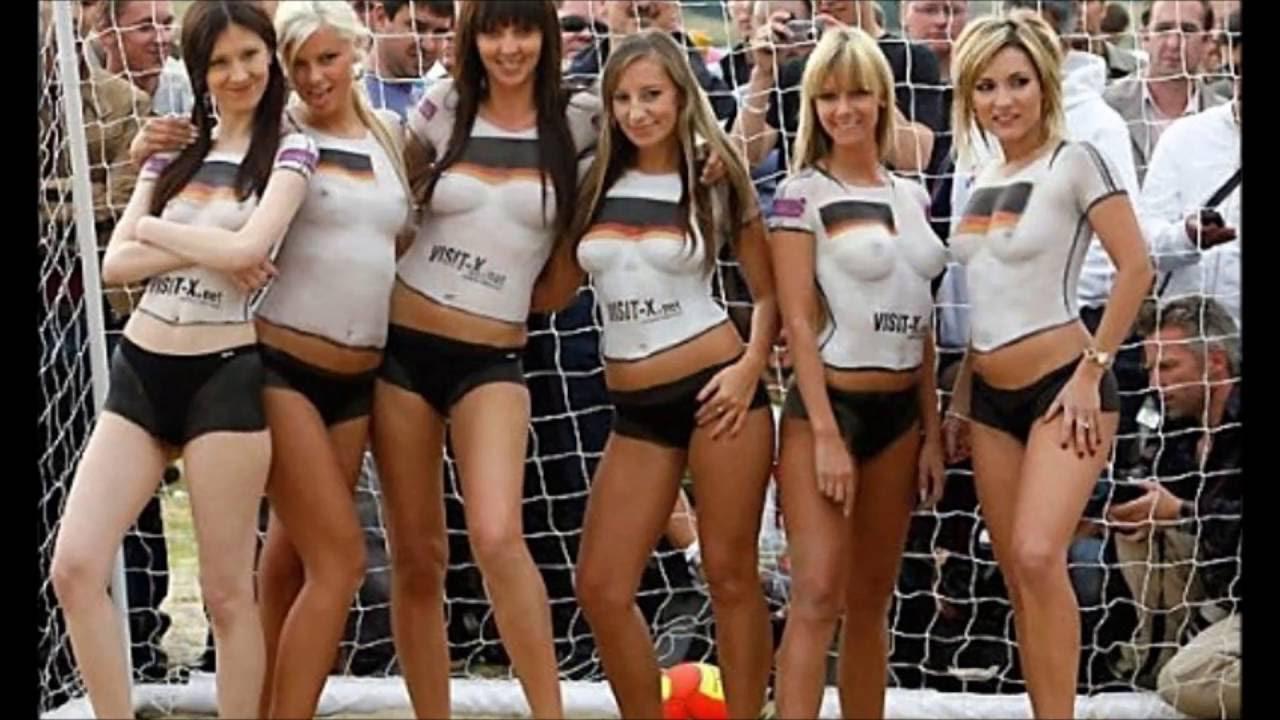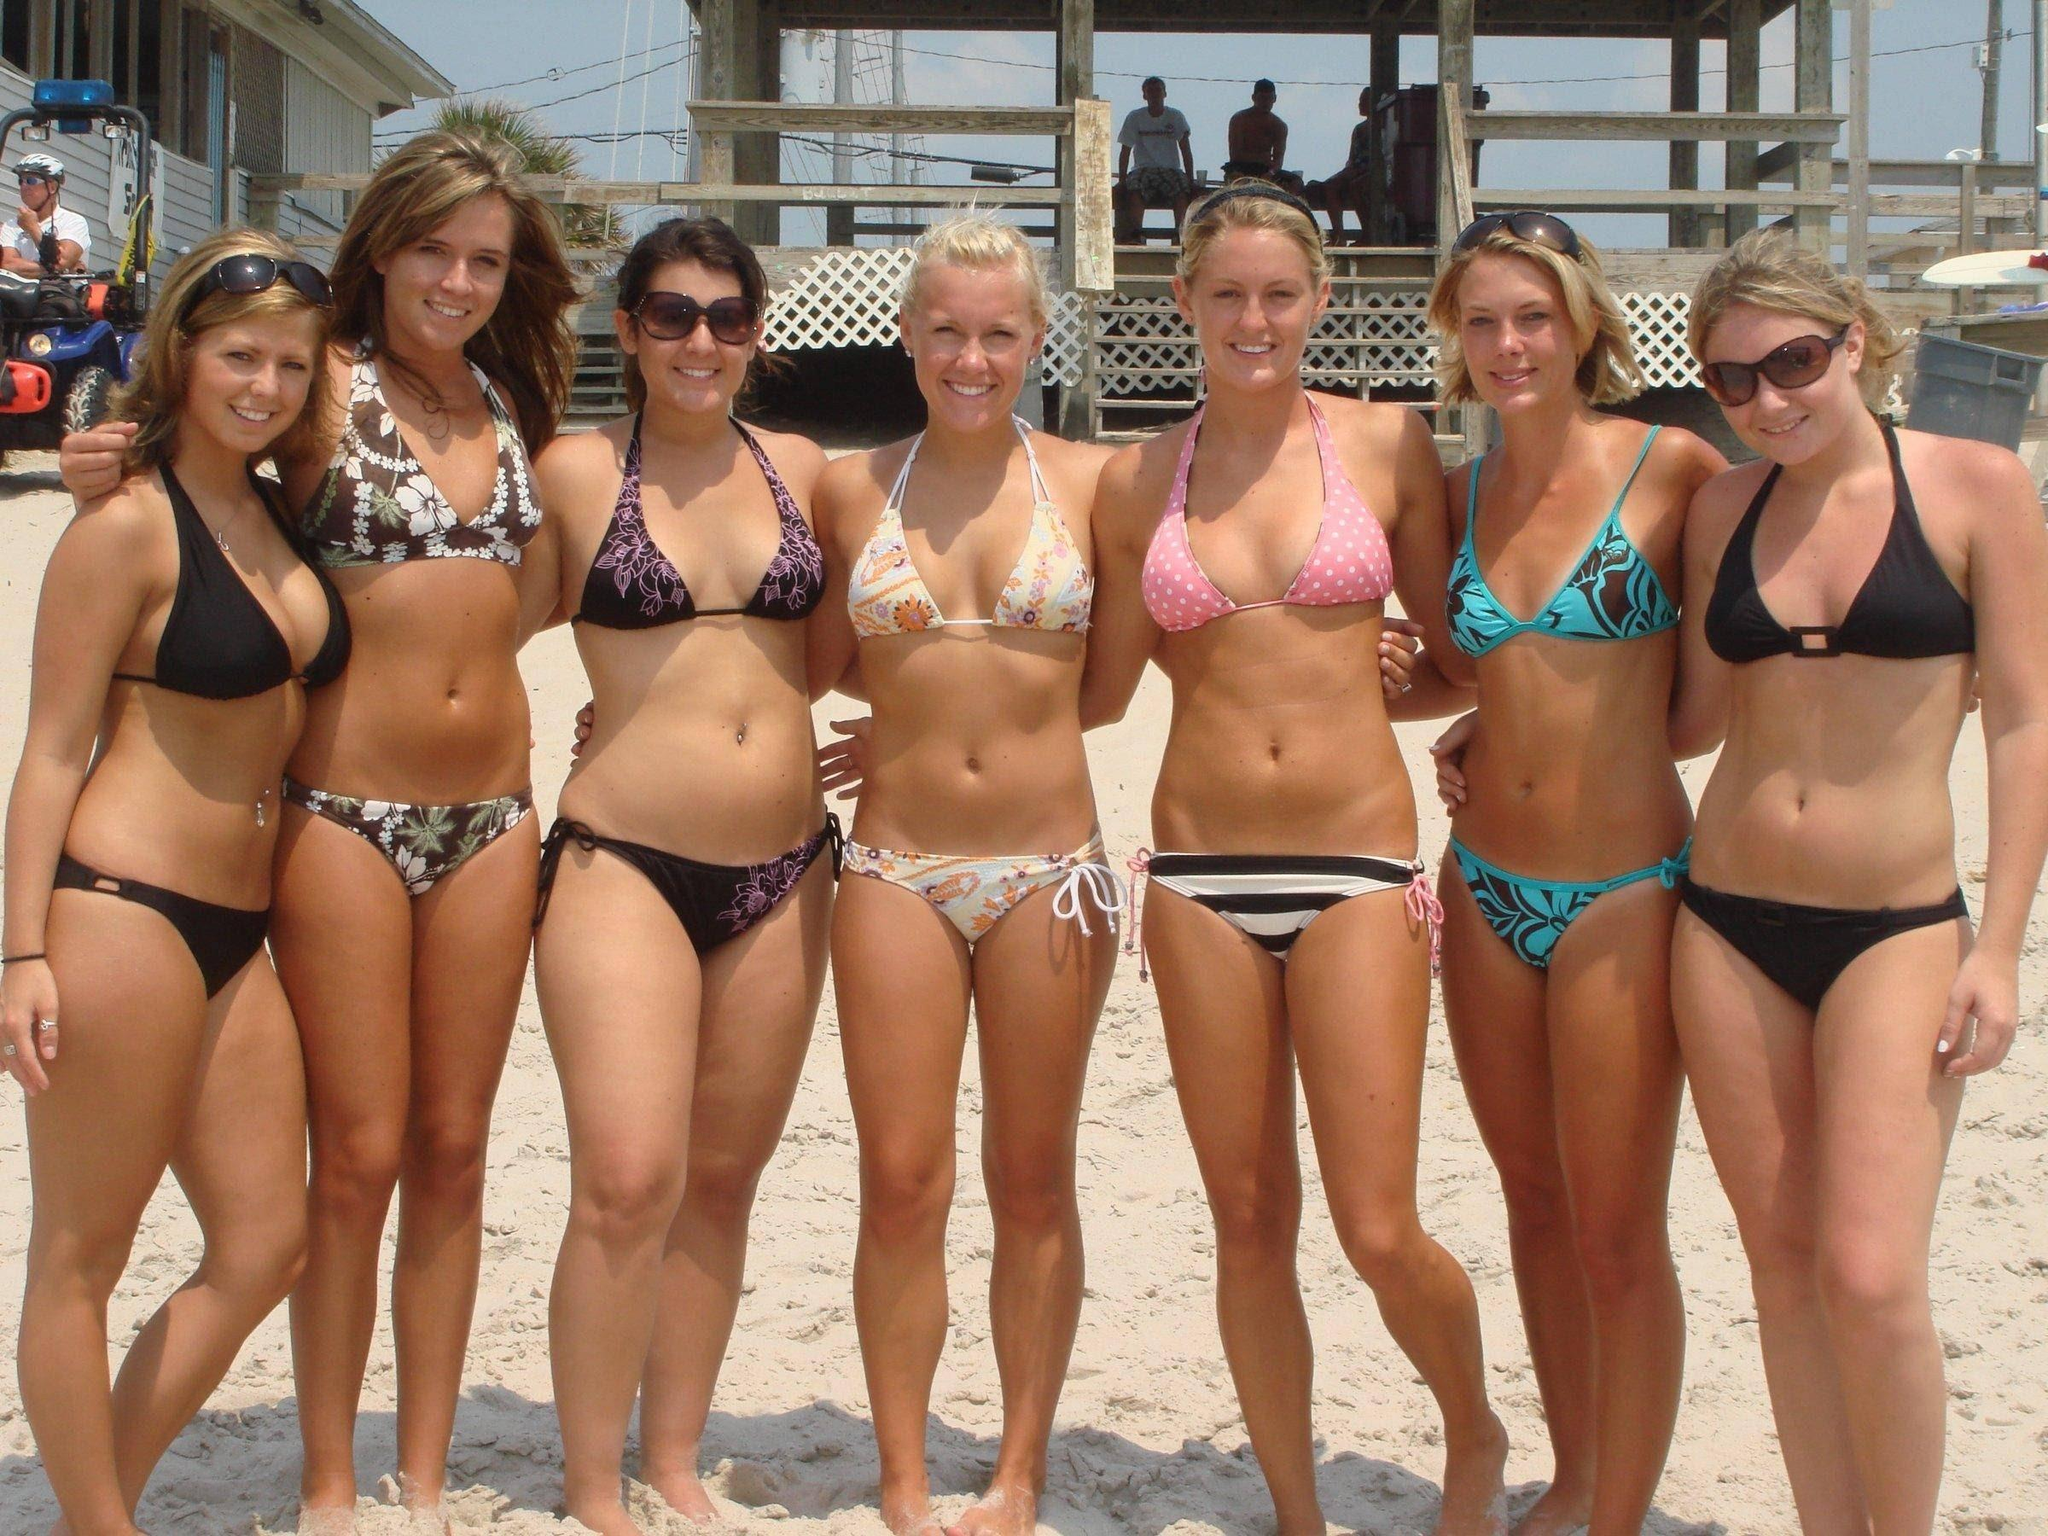The first image is the image on the left, the second image is the image on the right. For the images displayed, is the sentence "There are 6 women lined up for a photo in the left image." factually correct? Answer yes or no. Yes. 